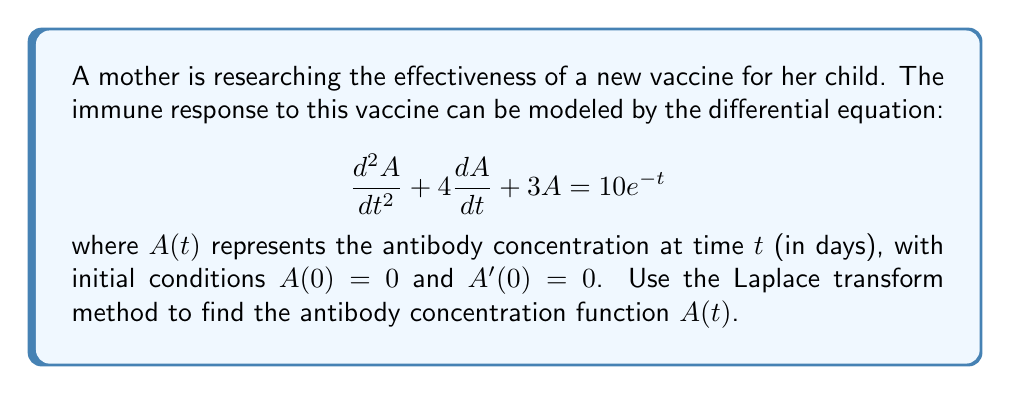Can you answer this question? Let's solve this step-by-step using the Laplace transform method:

1) Take the Laplace transform of both sides of the equation:
   $$\mathcal{L}\{A''(t) + 4A'(t) + 3A(t)\} = \mathcal{L}\{10e^{-t}\}$$

2) Using Laplace transform properties:
   $$[s^2\mathcal{L}\{A(t)\} - sA(0) - A'(0)] + 4[s\mathcal{L}\{A(t)\} - A(0)] + 3\mathcal{L}\{A(t)\} = \frac{10}{s+1}$$

3) Substitute the initial conditions $A(0) = 0$ and $A'(0) = 0$:
   $$s^2\mathcal{L}\{A(t)\} + 4s\mathcal{L}\{A(t)\} + 3\mathcal{L}\{A(t)\} = \frac{10}{s+1}$$

4) Factor out $\mathcal{L}\{A(t)\}$:
   $$\mathcal{L}\{A(t)\}(s^2 + 4s + 3) = \frac{10}{s+1}$$

5) Solve for $\mathcal{L}\{A(t)\}$:
   $$\mathcal{L}\{A(t)\} = \frac{10}{(s^2 + 4s + 3)(s+1)} = \frac{10}{(s+1)(s+1)(s+3)}$$

6) Perform partial fraction decomposition:
   $$\mathcal{L}\{A(t)\} = \frac{5/2}{(s+1)} - \frac{5/2}{(s+1)^2} - \frac{5/2}{(s+3)}$$

7) Take the inverse Laplace transform:
   $$A(t) = \frac{5}{2}e^{-t} - \frac{5}{2}te^{-t} - \frac{5}{2}e^{-3t}$$

8) Simplify:
   $$A(t) = \frac{5}{2}e^{-t}(1 - t) - \frac{5}{2}e^{-3t}$$

This function $A(t)$ represents the antibody concentration over time after vaccination.
Answer: $A(t) = \frac{5}{2}e^{-t}(1 - t) - \frac{5}{2}e^{-3t}$ 